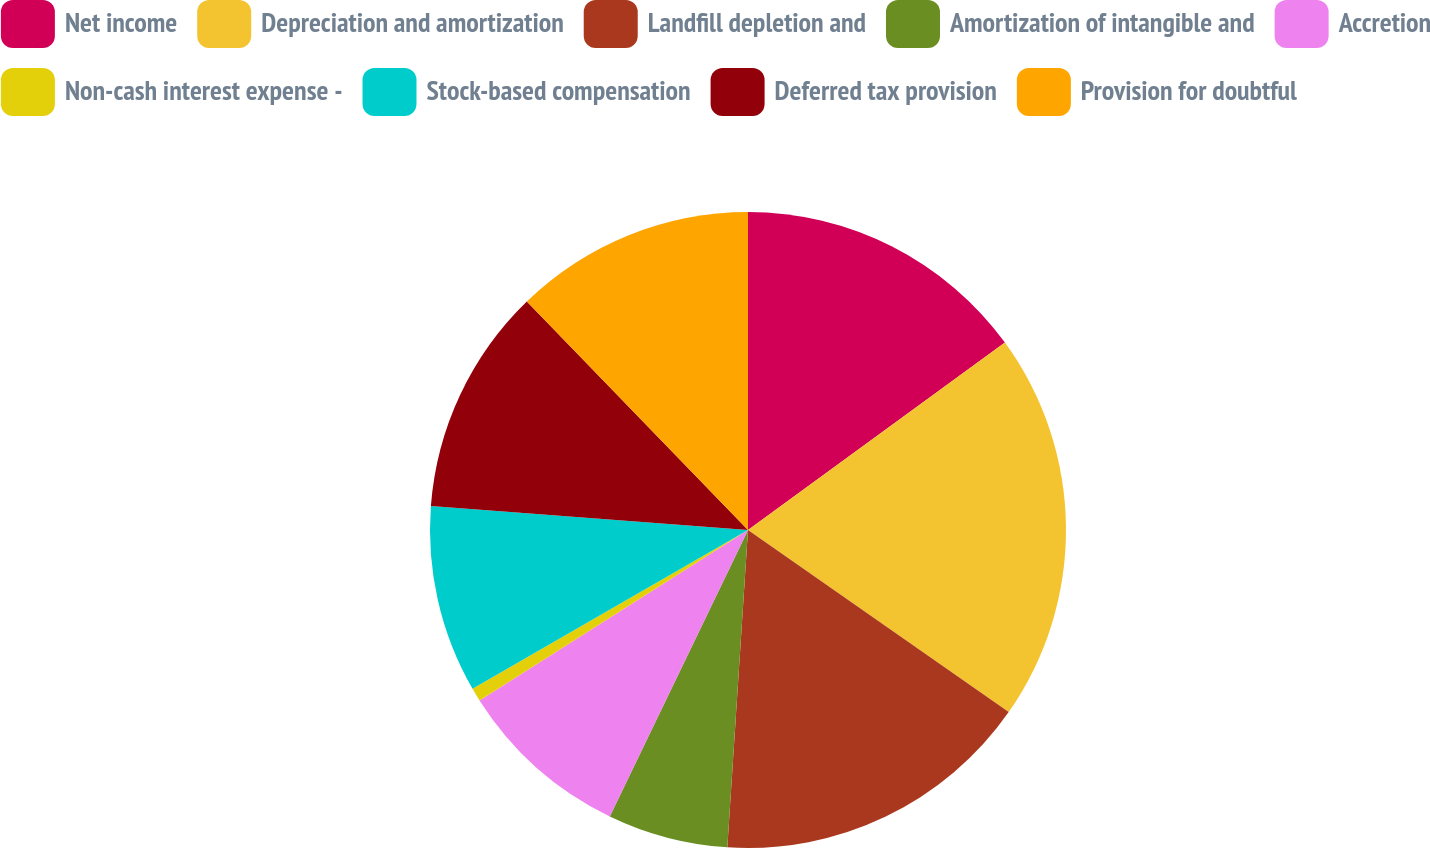<chart> <loc_0><loc_0><loc_500><loc_500><pie_chart><fcel>Net income<fcel>Depreciation and amortization<fcel>Landfill depletion and<fcel>Amortization of intangible and<fcel>Accretion<fcel>Non-cash interest expense -<fcel>Stock-based compensation<fcel>Deferred tax provision<fcel>Provision for doubtful<nl><fcel>14.97%<fcel>19.73%<fcel>16.33%<fcel>6.12%<fcel>8.84%<fcel>0.68%<fcel>9.52%<fcel>11.56%<fcel>12.24%<nl></chart> 